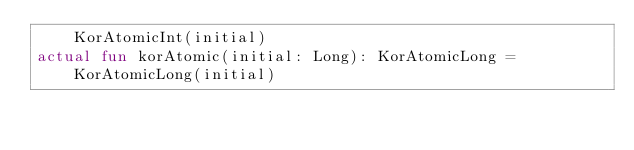<code> <loc_0><loc_0><loc_500><loc_500><_Kotlin_>	KorAtomicInt(initial)
actual fun korAtomic(initial: Long): KorAtomicLong =
	KorAtomicLong(initial)
</code> 